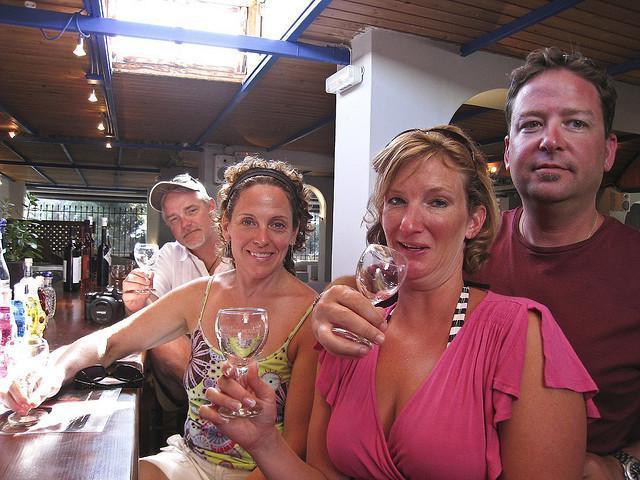How many people are wearing hats?
Give a very brief answer. 1. How many people can you see?
Give a very brief answer. 4. How many wine glasses can be seen?
Give a very brief answer. 2. 